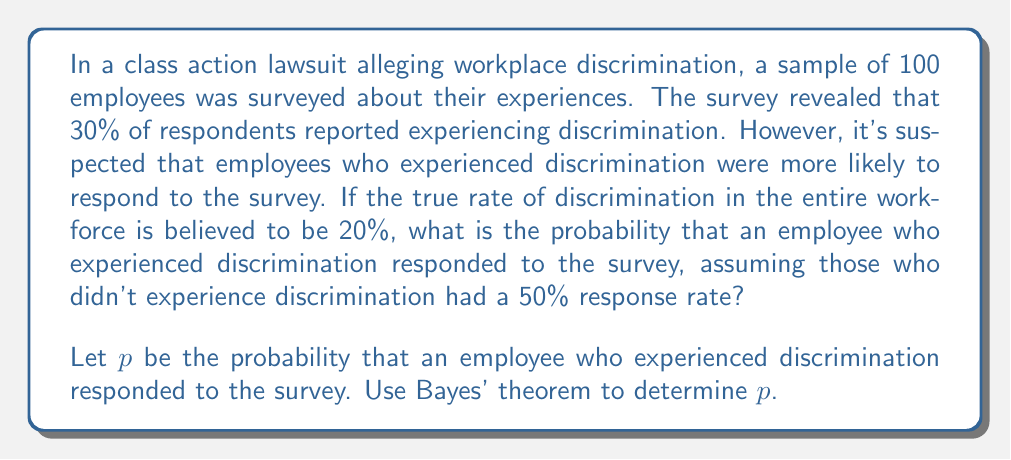Show me your answer to this math problem. To solve this inverse problem, we'll use Bayes' theorem and the given information. Let's define the events:

A: Employee experienced discrimination
B: Employee responded to the survey

Given:
P(A) = 0.20 (true rate of discrimination)
P(B|not A) = 0.50 (response rate for those who didn't experience discrimination)
P(A|B) = 0.30 (30% of respondents reported discrimination)

We need to find P(B|A) = p

Step 1: Write Bayes' theorem for P(A|B):
$$P(A|B) = \frac{P(B|A)P(A)}{P(B)}$$

Step 2: Express P(B) using the law of total probability:
$$P(B) = P(B|A)P(A) + P(B|not A)P(not A)$$

Step 3: Substitute the known values into Bayes' theorem:
$$0.30 = \frac{p \cdot 0.20}{p \cdot 0.20 + 0.50 \cdot 0.80}$$

Step 4: Solve for p:
$$0.30(p \cdot 0.20 + 0.50 \cdot 0.80) = p \cdot 0.20$$
$$0.06p + 0.12 = 0.20p$$
$$0.12 = 0.14p$$
$$p = \frac{0.12}{0.14} \approx 0.8571$$

Therefore, the probability that an employee who experienced discrimination responded to the survey is approximately 0.8571 or 85.71%.
Answer: 0.8571 